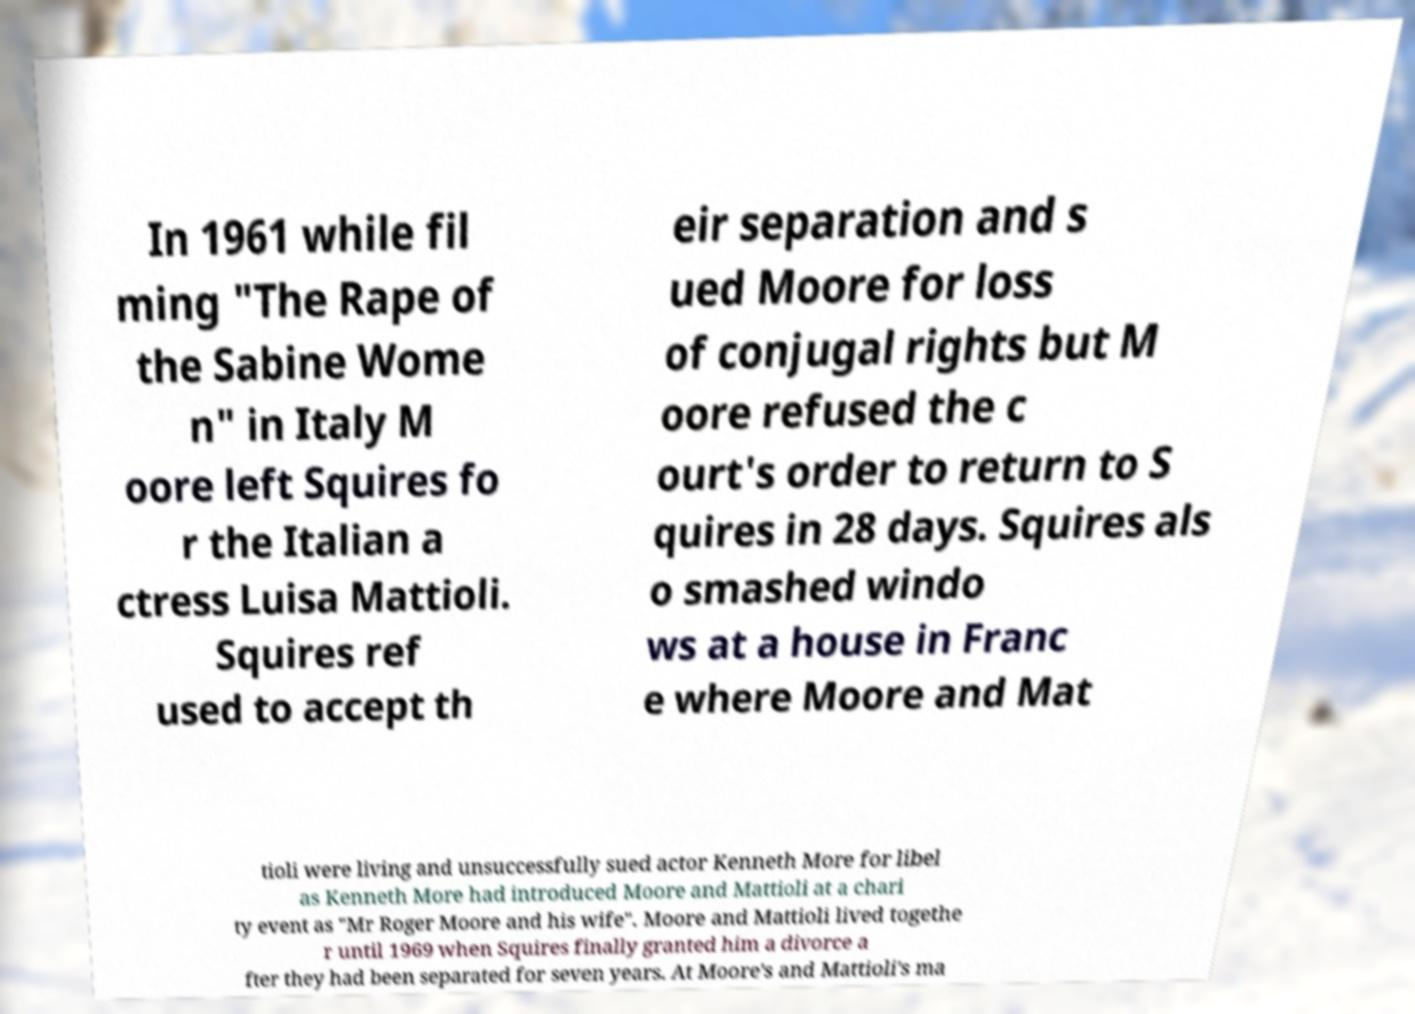Could you assist in decoding the text presented in this image and type it out clearly? In 1961 while fil ming "The Rape of the Sabine Wome n" in Italy M oore left Squires fo r the Italian a ctress Luisa Mattioli. Squires ref used to accept th eir separation and s ued Moore for loss of conjugal rights but M oore refused the c ourt's order to return to S quires in 28 days. Squires als o smashed windo ws at a house in Franc e where Moore and Mat tioli were living and unsuccessfully sued actor Kenneth More for libel as Kenneth More had introduced Moore and Mattioli at a chari ty event as "Mr Roger Moore and his wife". Moore and Mattioli lived togethe r until 1969 when Squires finally granted him a divorce a fter they had been separated for seven years. At Moore's and Mattioli's ma 